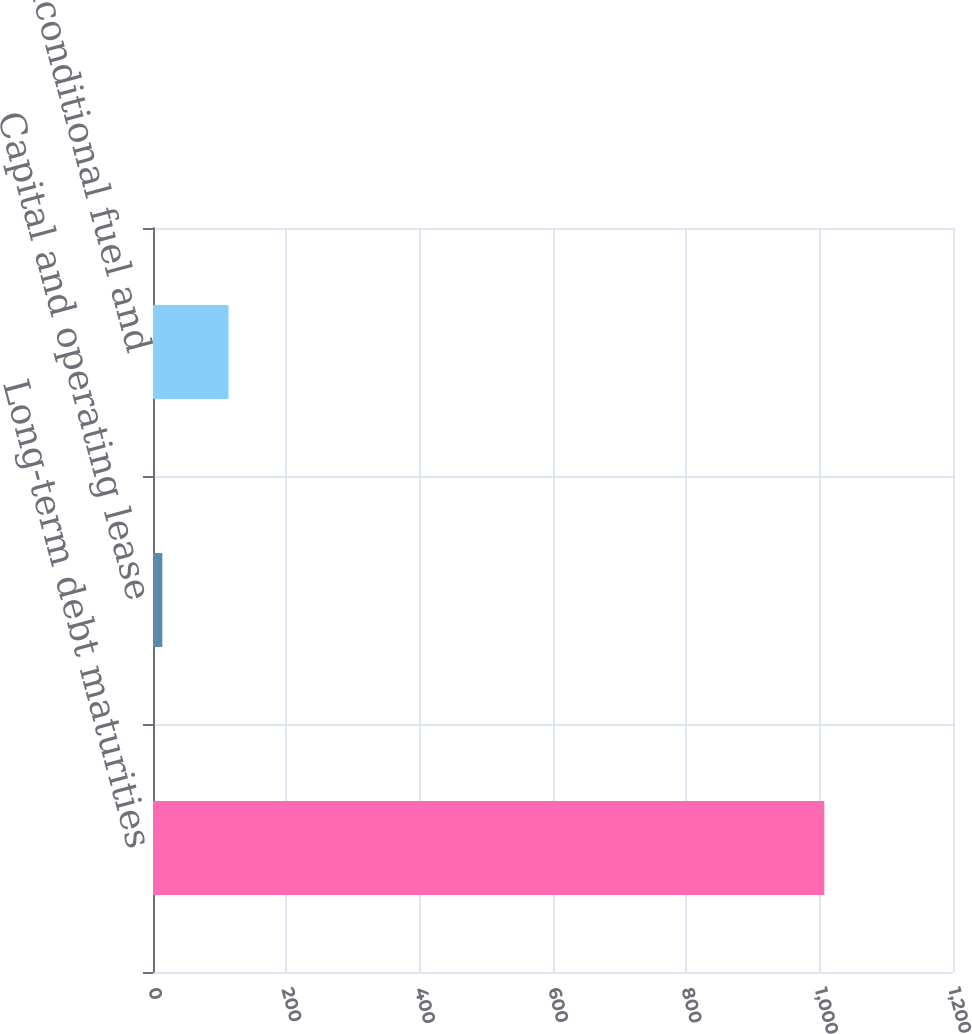Convert chart to OTSL. <chart><loc_0><loc_0><loc_500><loc_500><bar_chart><fcel>Long-term debt maturities<fcel>Capital and operating lease<fcel>Unconditional fuel and<nl><fcel>1007<fcel>14<fcel>113.3<nl></chart> 